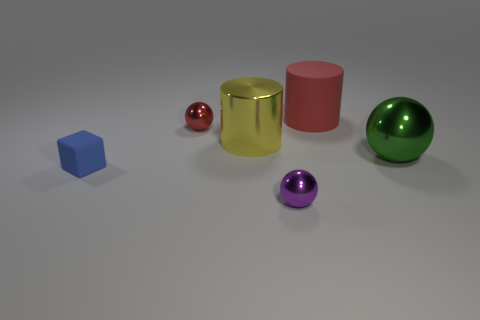How many small metal balls have the same color as the large rubber cylinder?
Ensure brevity in your answer.  1. There is a large matte object that is behind the big green sphere; is it the same color as the small ball behind the block?
Your answer should be compact. Yes. How many other objects are the same color as the big rubber thing?
Offer a very short reply. 1. Are there more red matte cylinders than yellow cubes?
Keep it short and to the point. Yes. There is a blue cube; does it have the same size as the cylinder that is in front of the small red object?
Offer a very short reply. No. What color is the ball to the right of the tiny purple sphere?
Provide a succinct answer. Green. How many blue objects are tiny metal balls or tiny matte cubes?
Ensure brevity in your answer.  1. What color is the big rubber cylinder?
Give a very brief answer. Red. Is there anything else that has the same material as the large ball?
Give a very brief answer. Yes. Are there fewer large yellow objects that are in front of the tiny blue rubber block than large cylinders that are in front of the small red metallic ball?
Offer a terse response. Yes. 